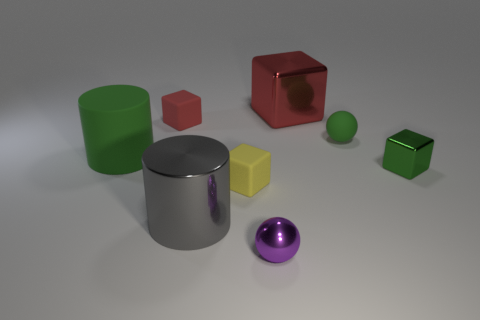Subtract all big red blocks. How many blocks are left? 3 Subtract 1 cubes. How many cubes are left? 3 Subtract all green cubes. How many cubes are left? 3 Add 1 tiny green metal cubes. How many objects exist? 9 Subtract all cyan blocks. Subtract all gray spheres. How many blocks are left? 4 Subtract all small rubber things. Subtract all purple shiny spheres. How many objects are left? 4 Add 6 green matte cylinders. How many green matte cylinders are left? 7 Add 3 gray blocks. How many gray blocks exist? 3 Subtract 0 brown cylinders. How many objects are left? 8 Subtract all spheres. How many objects are left? 6 